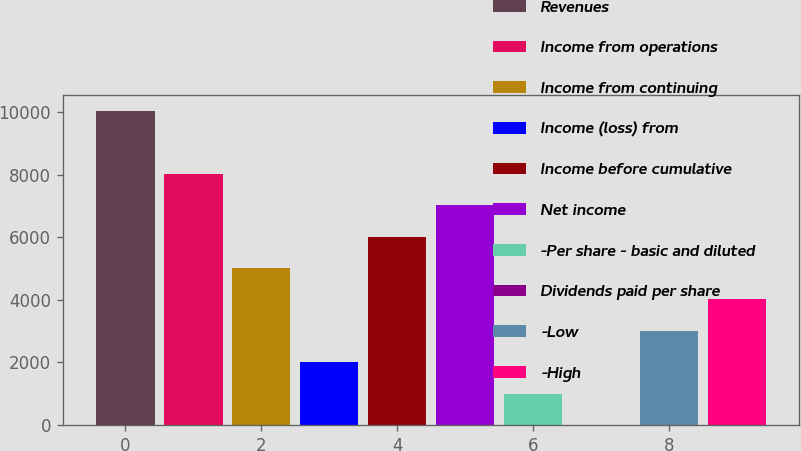Convert chart. <chart><loc_0><loc_0><loc_500><loc_500><bar_chart><fcel>Revenues<fcel>Income from operations<fcel>Income from continuing<fcel>Income (loss) from<fcel>Income before cumulative<fcel>Net income<fcel>-Per share - basic and diluted<fcel>Dividends paid per share<fcel>-Low<fcel>-High<nl><fcel>10033<fcel>8026.47<fcel>5016.63<fcel>2006.79<fcel>6019.91<fcel>7023.19<fcel>1003.51<fcel>0.23<fcel>3010.07<fcel>4013.35<nl></chart> 